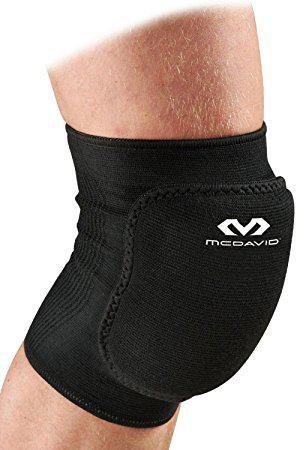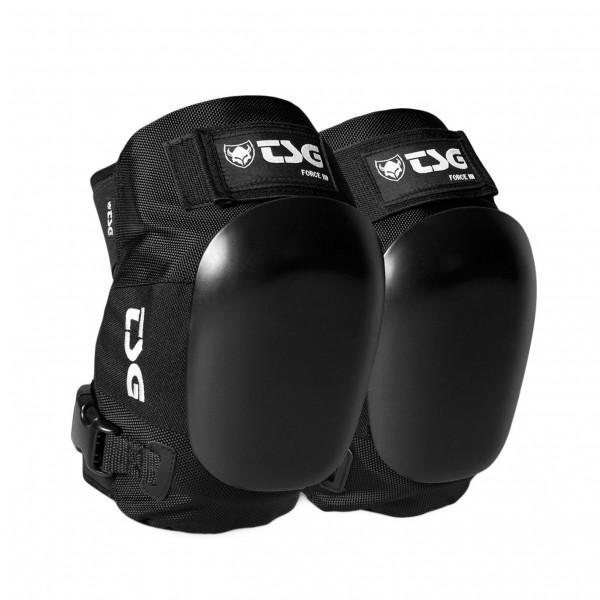The first image is the image on the left, the second image is the image on the right. Assess this claim about the two images: "Exactly two pairs of knee pads are shown, each solid black with logos, one pair viewed from the front and one at an angle to give a side view.". Correct or not? Answer yes or no. No. The first image is the image on the left, the second image is the image on the right. Examine the images to the left and right. Is the description "At least one kneepad appears to be worn on a leg, and all kneepads are facing rightwards." accurate? Answer yes or no. Yes. 